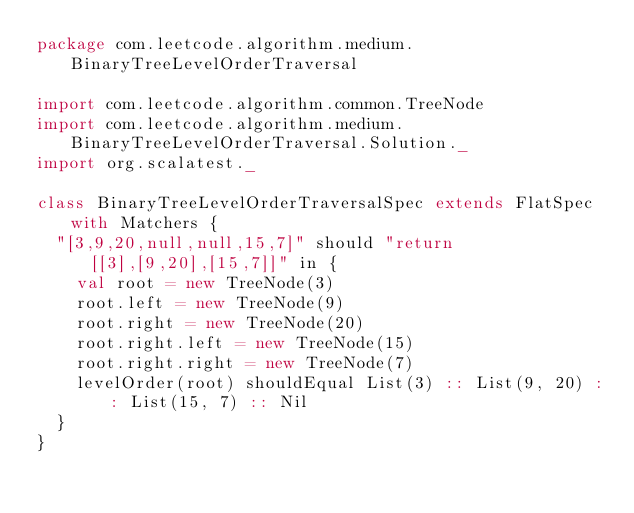Convert code to text. <code><loc_0><loc_0><loc_500><loc_500><_Scala_>package com.leetcode.algorithm.medium.BinaryTreeLevelOrderTraversal

import com.leetcode.algorithm.common.TreeNode
import com.leetcode.algorithm.medium.BinaryTreeLevelOrderTraversal.Solution._
import org.scalatest._

class BinaryTreeLevelOrderTraversalSpec extends FlatSpec with Matchers {
  "[3,9,20,null,null,15,7]" should "return [[3],[9,20],[15,7]]" in {
    val root = new TreeNode(3)
    root.left = new TreeNode(9)
    root.right = new TreeNode(20)
    root.right.left = new TreeNode(15)
    root.right.right = new TreeNode(7)
    levelOrder(root) shouldEqual List(3) :: List(9, 20) :: List(15, 7) :: Nil
  }
}
</code> 